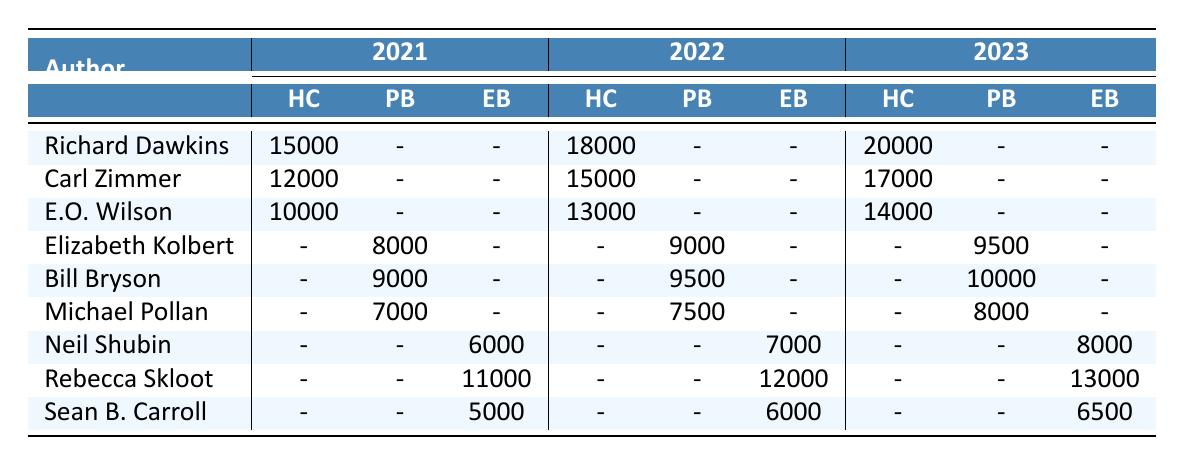What was the total sales of Richard Dawkins' books across all formats in 2023? Richard Dawkins sold 20,000 copies in hardcover, with no sales in other formats, so the total sales is 20,000 + 0 + 0 = 20,000.
Answer: 20,000 Which author had the highest sales in paperback in 2022? In 2022, the paperback sales were 9,000 for Elizabeth Kolbert, 9,500 for Bill Bryson, and 7,500 for Michael Pollan. The highest sales in paperback were 9,500 by Bill Bryson.
Answer: Bill Bryson Did E.O. Wilson have any sales in paperback in 2021? E.O. Wilson had 10,000 sales in hardcover in 2021, but there are no sales listed for him in paperback. Thus, the statement is false.
Answer: No What format had the lowest sales for Rebecca Skloot in 2021? In 2021, Rebecca Skloot sold 11,000 in ebook format, and she had no sales in hardcover or paperback. Therefore, the lowest sales were in hardcover and paperback, which had 0 sales.
Answer: Hardcover and paperback What was the growth in hardcover sales for Richard Dawkins from 2021 to 2023? Richard Dawkins sold 15,000 copies in hardcover in 2021 and 20,000 copies in 2023. The growth is calculated by 20,000 - 15,000 = 5,000.
Answer: 5,000 What was the average sales for Sean B. Carroll across all years and formats? Sean B. Carroll had sales of 5,000 in 2021, 6,000 in 2022, and 6,500 in 2023 in ebook format. The average is calculated as (5,000 + 6,000 + 6,500) / 3 = 5,833.33, rounded down to 5,833.
Answer: 5,833 Which author had the most consistent sales across the three years, based on their total sales? To find the most consistent author, we calculate the total sales for each author by year. Richard Dawkins' sales increased each year (15,000 to 20,000), while others had fluctuations. Michael Pollan had 7,000, 7,500, and 8,000, which is a steady increase. The author with the least variation is Michael Pollan with a difference of 1,000 over three years.
Answer: Michael Pollan What was the difference in total sales between hardcover and ebook formats for any author in 2022? For Richard Dawkins in 2022, the hardcover sales were 18,000 and the ebook sales were 0, so the difference is 18,000. For others like Carl Zimmer it was 15,000 for hardcover and 0 for ebook; the highest difference was therefore for Richard Dawkins.
Answer: 18,000 Which format consistently had zero sales for all authors in 2021? The paperback format had no sales for Richard Dawkins, Carl Zimmer, and E.O. Wilson in 2021, meaning the format had consistent zero sales for them.
Answer: Paperback 